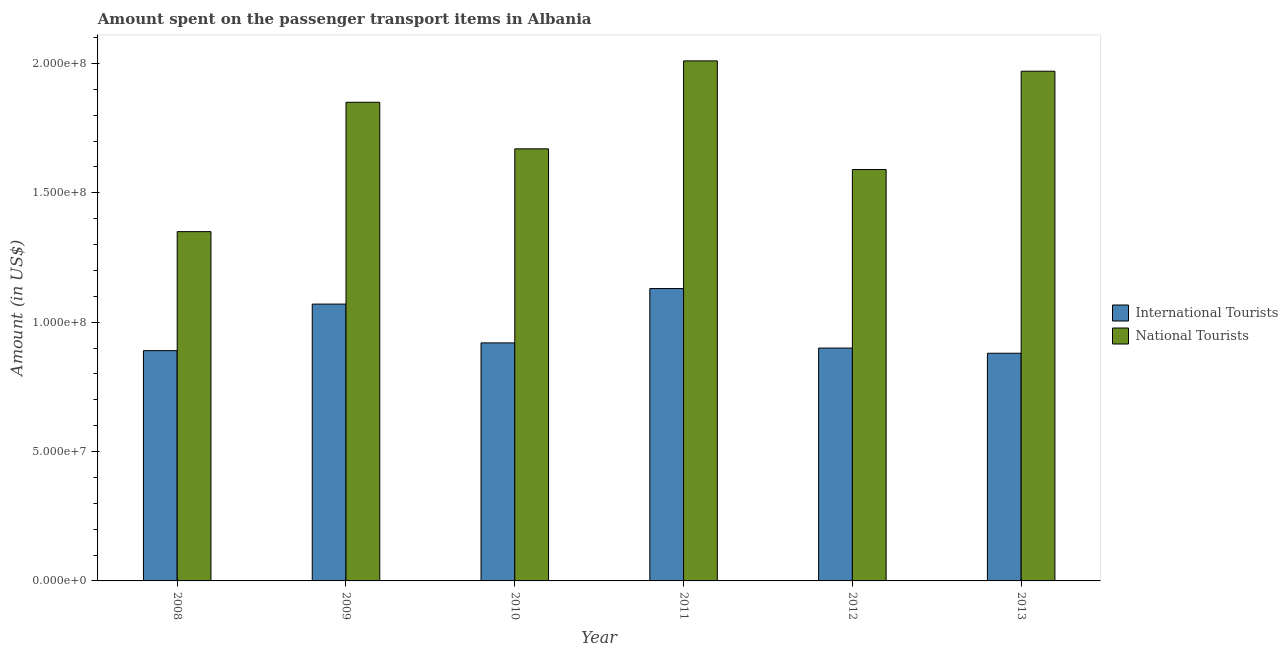How many groups of bars are there?
Provide a succinct answer. 6. How many bars are there on the 1st tick from the left?
Provide a short and direct response. 2. What is the label of the 2nd group of bars from the left?
Your answer should be very brief. 2009. What is the amount spent on transport items of international tourists in 2012?
Provide a succinct answer. 9.00e+07. Across all years, what is the maximum amount spent on transport items of international tourists?
Keep it short and to the point. 1.13e+08. Across all years, what is the minimum amount spent on transport items of international tourists?
Ensure brevity in your answer.  8.80e+07. In which year was the amount spent on transport items of international tourists maximum?
Your answer should be compact. 2011. In which year was the amount spent on transport items of international tourists minimum?
Offer a very short reply. 2013. What is the total amount spent on transport items of international tourists in the graph?
Your answer should be compact. 5.79e+08. What is the difference between the amount spent on transport items of international tourists in 2011 and that in 2012?
Your answer should be compact. 2.30e+07. What is the difference between the amount spent on transport items of international tourists in 2011 and the amount spent on transport items of national tourists in 2008?
Provide a succinct answer. 2.40e+07. What is the average amount spent on transport items of national tourists per year?
Provide a short and direct response. 1.74e+08. In the year 2013, what is the difference between the amount spent on transport items of international tourists and amount spent on transport items of national tourists?
Provide a short and direct response. 0. What is the ratio of the amount spent on transport items of national tourists in 2011 to that in 2012?
Your answer should be compact. 1.26. Is the amount spent on transport items of international tourists in 2012 less than that in 2013?
Keep it short and to the point. No. Is the difference between the amount spent on transport items of national tourists in 2009 and 2012 greater than the difference between the amount spent on transport items of international tourists in 2009 and 2012?
Provide a succinct answer. No. What is the difference between the highest and the second highest amount spent on transport items of international tourists?
Your answer should be very brief. 6.00e+06. What is the difference between the highest and the lowest amount spent on transport items of international tourists?
Your response must be concise. 2.50e+07. In how many years, is the amount spent on transport items of international tourists greater than the average amount spent on transport items of international tourists taken over all years?
Your answer should be very brief. 2. Is the sum of the amount spent on transport items of international tourists in 2009 and 2011 greater than the maximum amount spent on transport items of national tourists across all years?
Offer a terse response. Yes. What does the 2nd bar from the left in 2013 represents?
Your response must be concise. National Tourists. What does the 1st bar from the right in 2009 represents?
Offer a very short reply. National Tourists. How many bars are there?
Provide a short and direct response. 12. Are all the bars in the graph horizontal?
Keep it short and to the point. No. How many years are there in the graph?
Your response must be concise. 6. Does the graph contain grids?
Make the answer very short. No. Where does the legend appear in the graph?
Give a very brief answer. Center right. How many legend labels are there?
Your response must be concise. 2. How are the legend labels stacked?
Provide a succinct answer. Vertical. What is the title of the graph?
Provide a succinct answer. Amount spent on the passenger transport items in Albania. Does "Arms exports" appear as one of the legend labels in the graph?
Your response must be concise. No. What is the label or title of the Y-axis?
Your response must be concise. Amount (in US$). What is the Amount (in US$) in International Tourists in 2008?
Keep it short and to the point. 8.90e+07. What is the Amount (in US$) of National Tourists in 2008?
Provide a succinct answer. 1.35e+08. What is the Amount (in US$) in International Tourists in 2009?
Give a very brief answer. 1.07e+08. What is the Amount (in US$) of National Tourists in 2009?
Keep it short and to the point. 1.85e+08. What is the Amount (in US$) of International Tourists in 2010?
Offer a very short reply. 9.20e+07. What is the Amount (in US$) of National Tourists in 2010?
Provide a short and direct response. 1.67e+08. What is the Amount (in US$) of International Tourists in 2011?
Your response must be concise. 1.13e+08. What is the Amount (in US$) in National Tourists in 2011?
Make the answer very short. 2.01e+08. What is the Amount (in US$) in International Tourists in 2012?
Keep it short and to the point. 9.00e+07. What is the Amount (in US$) of National Tourists in 2012?
Your response must be concise. 1.59e+08. What is the Amount (in US$) in International Tourists in 2013?
Your response must be concise. 8.80e+07. What is the Amount (in US$) in National Tourists in 2013?
Your answer should be compact. 1.97e+08. Across all years, what is the maximum Amount (in US$) of International Tourists?
Your response must be concise. 1.13e+08. Across all years, what is the maximum Amount (in US$) of National Tourists?
Make the answer very short. 2.01e+08. Across all years, what is the minimum Amount (in US$) of International Tourists?
Ensure brevity in your answer.  8.80e+07. Across all years, what is the minimum Amount (in US$) of National Tourists?
Offer a terse response. 1.35e+08. What is the total Amount (in US$) in International Tourists in the graph?
Your response must be concise. 5.79e+08. What is the total Amount (in US$) in National Tourists in the graph?
Keep it short and to the point. 1.04e+09. What is the difference between the Amount (in US$) of International Tourists in 2008 and that in 2009?
Your answer should be very brief. -1.80e+07. What is the difference between the Amount (in US$) of National Tourists in 2008 and that in 2009?
Ensure brevity in your answer.  -5.00e+07. What is the difference between the Amount (in US$) in International Tourists in 2008 and that in 2010?
Provide a short and direct response. -3.00e+06. What is the difference between the Amount (in US$) of National Tourists in 2008 and that in 2010?
Your answer should be compact. -3.20e+07. What is the difference between the Amount (in US$) in International Tourists in 2008 and that in 2011?
Your answer should be very brief. -2.40e+07. What is the difference between the Amount (in US$) of National Tourists in 2008 and that in 2011?
Keep it short and to the point. -6.60e+07. What is the difference between the Amount (in US$) of International Tourists in 2008 and that in 2012?
Provide a short and direct response. -1.00e+06. What is the difference between the Amount (in US$) of National Tourists in 2008 and that in 2012?
Your answer should be very brief. -2.40e+07. What is the difference between the Amount (in US$) in National Tourists in 2008 and that in 2013?
Give a very brief answer. -6.20e+07. What is the difference between the Amount (in US$) of International Tourists in 2009 and that in 2010?
Your answer should be very brief. 1.50e+07. What is the difference between the Amount (in US$) of National Tourists in 2009 and that in 2010?
Your answer should be very brief. 1.80e+07. What is the difference between the Amount (in US$) of International Tourists in 2009 and that in 2011?
Offer a very short reply. -6.00e+06. What is the difference between the Amount (in US$) of National Tourists in 2009 and that in 2011?
Give a very brief answer. -1.60e+07. What is the difference between the Amount (in US$) of International Tourists in 2009 and that in 2012?
Provide a short and direct response. 1.70e+07. What is the difference between the Amount (in US$) in National Tourists in 2009 and that in 2012?
Offer a very short reply. 2.60e+07. What is the difference between the Amount (in US$) in International Tourists in 2009 and that in 2013?
Offer a very short reply. 1.90e+07. What is the difference between the Amount (in US$) of National Tourists in 2009 and that in 2013?
Make the answer very short. -1.20e+07. What is the difference between the Amount (in US$) of International Tourists in 2010 and that in 2011?
Your answer should be compact. -2.10e+07. What is the difference between the Amount (in US$) in National Tourists in 2010 and that in 2011?
Provide a succinct answer. -3.40e+07. What is the difference between the Amount (in US$) of International Tourists in 2010 and that in 2013?
Keep it short and to the point. 4.00e+06. What is the difference between the Amount (in US$) of National Tourists in 2010 and that in 2013?
Offer a very short reply. -3.00e+07. What is the difference between the Amount (in US$) of International Tourists in 2011 and that in 2012?
Provide a short and direct response. 2.30e+07. What is the difference between the Amount (in US$) of National Tourists in 2011 and that in 2012?
Your answer should be very brief. 4.20e+07. What is the difference between the Amount (in US$) of International Tourists in 2011 and that in 2013?
Provide a short and direct response. 2.50e+07. What is the difference between the Amount (in US$) of National Tourists in 2012 and that in 2013?
Keep it short and to the point. -3.80e+07. What is the difference between the Amount (in US$) in International Tourists in 2008 and the Amount (in US$) in National Tourists in 2009?
Provide a succinct answer. -9.60e+07. What is the difference between the Amount (in US$) in International Tourists in 2008 and the Amount (in US$) in National Tourists in 2010?
Ensure brevity in your answer.  -7.80e+07. What is the difference between the Amount (in US$) in International Tourists in 2008 and the Amount (in US$) in National Tourists in 2011?
Your answer should be very brief. -1.12e+08. What is the difference between the Amount (in US$) of International Tourists in 2008 and the Amount (in US$) of National Tourists in 2012?
Keep it short and to the point. -7.00e+07. What is the difference between the Amount (in US$) in International Tourists in 2008 and the Amount (in US$) in National Tourists in 2013?
Your answer should be compact. -1.08e+08. What is the difference between the Amount (in US$) in International Tourists in 2009 and the Amount (in US$) in National Tourists in 2010?
Give a very brief answer. -6.00e+07. What is the difference between the Amount (in US$) in International Tourists in 2009 and the Amount (in US$) in National Tourists in 2011?
Make the answer very short. -9.40e+07. What is the difference between the Amount (in US$) of International Tourists in 2009 and the Amount (in US$) of National Tourists in 2012?
Offer a very short reply. -5.20e+07. What is the difference between the Amount (in US$) in International Tourists in 2009 and the Amount (in US$) in National Tourists in 2013?
Provide a short and direct response. -9.00e+07. What is the difference between the Amount (in US$) of International Tourists in 2010 and the Amount (in US$) of National Tourists in 2011?
Offer a very short reply. -1.09e+08. What is the difference between the Amount (in US$) of International Tourists in 2010 and the Amount (in US$) of National Tourists in 2012?
Ensure brevity in your answer.  -6.70e+07. What is the difference between the Amount (in US$) in International Tourists in 2010 and the Amount (in US$) in National Tourists in 2013?
Ensure brevity in your answer.  -1.05e+08. What is the difference between the Amount (in US$) of International Tourists in 2011 and the Amount (in US$) of National Tourists in 2012?
Provide a short and direct response. -4.60e+07. What is the difference between the Amount (in US$) in International Tourists in 2011 and the Amount (in US$) in National Tourists in 2013?
Ensure brevity in your answer.  -8.40e+07. What is the difference between the Amount (in US$) in International Tourists in 2012 and the Amount (in US$) in National Tourists in 2013?
Offer a terse response. -1.07e+08. What is the average Amount (in US$) in International Tourists per year?
Provide a succinct answer. 9.65e+07. What is the average Amount (in US$) of National Tourists per year?
Make the answer very short. 1.74e+08. In the year 2008, what is the difference between the Amount (in US$) of International Tourists and Amount (in US$) of National Tourists?
Offer a terse response. -4.60e+07. In the year 2009, what is the difference between the Amount (in US$) of International Tourists and Amount (in US$) of National Tourists?
Make the answer very short. -7.80e+07. In the year 2010, what is the difference between the Amount (in US$) in International Tourists and Amount (in US$) in National Tourists?
Keep it short and to the point. -7.50e+07. In the year 2011, what is the difference between the Amount (in US$) in International Tourists and Amount (in US$) in National Tourists?
Your answer should be very brief. -8.80e+07. In the year 2012, what is the difference between the Amount (in US$) of International Tourists and Amount (in US$) of National Tourists?
Offer a terse response. -6.90e+07. In the year 2013, what is the difference between the Amount (in US$) in International Tourists and Amount (in US$) in National Tourists?
Give a very brief answer. -1.09e+08. What is the ratio of the Amount (in US$) of International Tourists in 2008 to that in 2009?
Give a very brief answer. 0.83. What is the ratio of the Amount (in US$) of National Tourists in 2008 to that in 2009?
Make the answer very short. 0.73. What is the ratio of the Amount (in US$) of International Tourists in 2008 to that in 2010?
Make the answer very short. 0.97. What is the ratio of the Amount (in US$) in National Tourists in 2008 to that in 2010?
Your answer should be very brief. 0.81. What is the ratio of the Amount (in US$) in International Tourists in 2008 to that in 2011?
Ensure brevity in your answer.  0.79. What is the ratio of the Amount (in US$) of National Tourists in 2008 to that in 2011?
Ensure brevity in your answer.  0.67. What is the ratio of the Amount (in US$) of International Tourists in 2008 to that in 2012?
Your answer should be very brief. 0.99. What is the ratio of the Amount (in US$) of National Tourists in 2008 to that in 2012?
Give a very brief answer. 0.85. What is the ratio of the Amount (in US$) of International Tourists in 2008 to that in 2013?
Offer a terse response. 1.01. What is the ratio of the Amount (in US$) in National Tourists in 2008 to that in 2013?
Your response must be concise. 0.69. What is the ratio of the Amount (in US$) of International Tourists in 2009 to that in 2010?
Provide a succinct answer. 1.16. What is the ratio of the Amount (in US$) in National Tourists in 2009 to that in 2010?
Your response must be concise. 1.11. What is the ratio of the Amount (in US$) of International Tourists in 2009 to that in 2011?
Make the answer very short. 0.95. What is the ratio of the Amount (in US$) in National Tourists in 2009 to that in 2011?
Offer a terse response. 0.92. What is the ratio of the Amount (in US$) of International Tourists in 2009 to that in 2012?
Give a very brief answer. 1.19. What is the ratio of the Amount (in US$) of National Tourists in 2009 to that in 2012?
Provide a short and direct response. 1.16. What is the ratio of the Amount (in US$) in International Tourists in 2009 to that in 2013?
Keep it short and to the point. 1.22. What is the ratio of the Amount (in US$) of National Tourists in 2009 to that in 2013?
Offer a terse response. 0.94. What is the ratio of the Amount (in US$) of International Tourists in 2010 to that in 2011?
Provide a succinct answer. 0.81. What is the ratio of the Amount (in US$) in National Tourists in 2010 to that in 2011?
Offer a very short reply. 0.83. What is the ratio of the Amount (in US$) of International Tourists in 2010 to that in 2012?
Your response must be concise. 1.02. What is the ratio of the Amount (in US$) in National Tourists in 2010 to that in 2012?
Give a very brief answer. 1.05. What is the ratio of the Amount (in US$) of International Tourists in 2010 to that in 2013?
Make the answer very short. 1.05. What is the ratio of the Amount (in US$) in National Tourists in 2010 to that in 2013?
Make the answer very short. 0.85. What is the ratio of the Amount (in US$) of International Tourists in 2011 to that in 2012?
Offer a terse response. 1.26. What is the ratio of the Amount (in US$) of National Tourists in 2011 to that in 2012?
Offer a terse response. 1.26. What is the ratio of the Amount (in US$) in International Tourists in 2011 to that in 2013?
Your response must be concise. 1.28. What is the ratio of the Amount (in US$) in National Tourists in 2011 to that in 2013?
Your response must be concise. 1.02. What is the ratio of the Amount (in US$) in International Tourists in 2012 to that in 2013?
Your response must be concise. 1.02. What is the ratio of the Amount (in US$) of National Tourists in 2012 to that in 2013?
Give a very brief answer. 0.81. What is the difference between the highest and the second highest Amount (in US$) in International Tourists?
Keep it short and to the point. 6.00e+06. What is the difference between the highest and the lowest Amount (in US$) of International Tourists?
Give a very brief answer. 2.50e+07. What is the difference between the highest and the lowest Amount (in US$) of National Tourists?
Ensure brevity in your answer.  6.60e+07. 